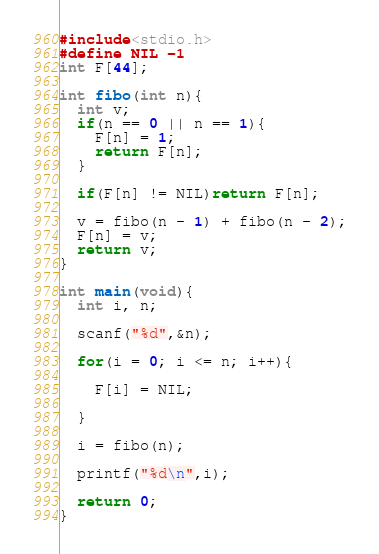<code> <loc_0><loc_0><loc_500><loc_500><_C_>#include<stdio.h>
#define NIL -1
int F[44];

int fibo(int n){
  int v;
  if(n == 0 || n == 1){
    F[n] = 1;
    return F[n];
  } 

  if(F[n] != NIL)return F[n];
  
  v = fibo(n - 1) + fibo(n - 2);
  F[n] = v;
  return v;
}

int main(void){
  int i, n;
  
  scanf("%d",&n);
  
  for(i = 0; i <= n; i++){
    
    F[i] = NIL;
    
  }
  
  i = fibo(n);
  
  printf("%d\n",i);
  
  return 0;
}</code> 